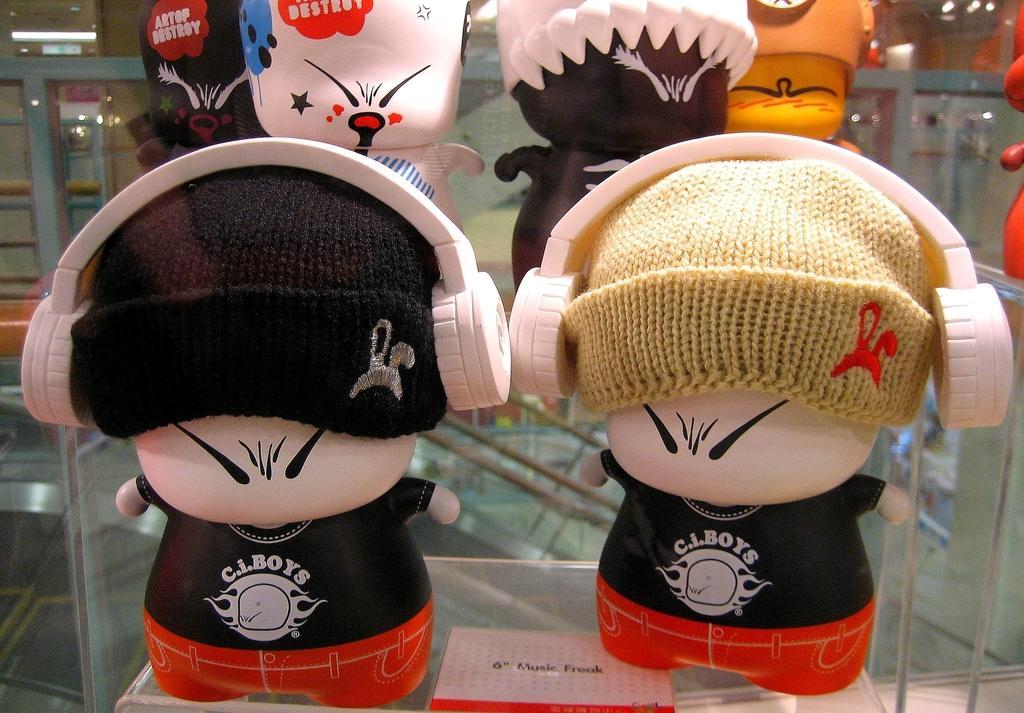How would you summarize this image in a sentence or two? In this image we can see some dolls which are placed on the racks. We can also see some ceiling lights to a roof. 